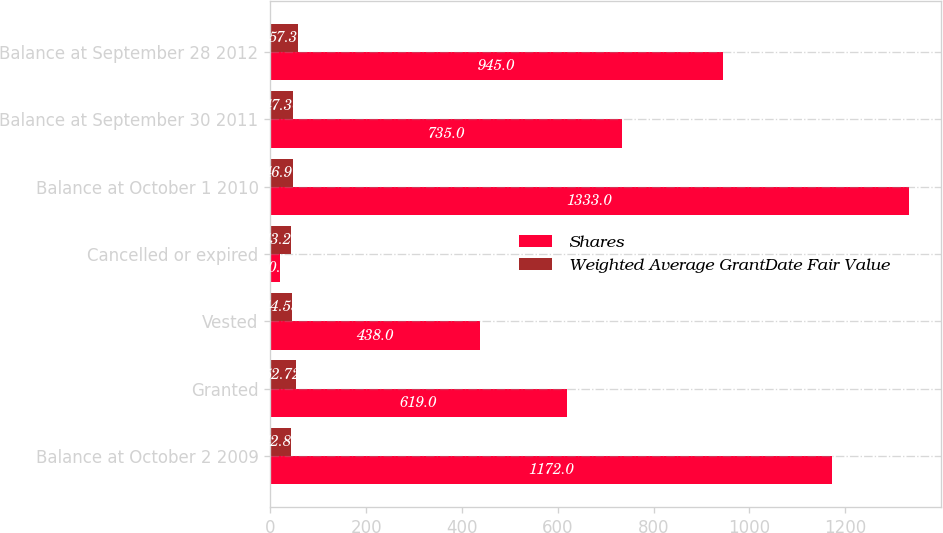<chart> <loc_0><loc_0><loc_500><loc_500><stacked_bar_chart><ecel><fcel>Balance at October 2 2009<fcel>Granted<fcel>Vested<fcel>Cancelled or expired<fcel>Balance at October 1 2010<fcel>Balance at September 30 2011<fcel>Balance at September 28 2012<nl><fcel>Shares<fcel>1172<fcel>619<fcel>438<fcel>20<fcel>1333<fcel>735<fcel>945<nl><fcel>Weighted Average GrantDate Fair Value<fcel>42.89<fcel>52.72<fcel>44.53<fcel>43.27<fcel>46.91<fcel>47.36<fcel>57.3<nl></chart> 